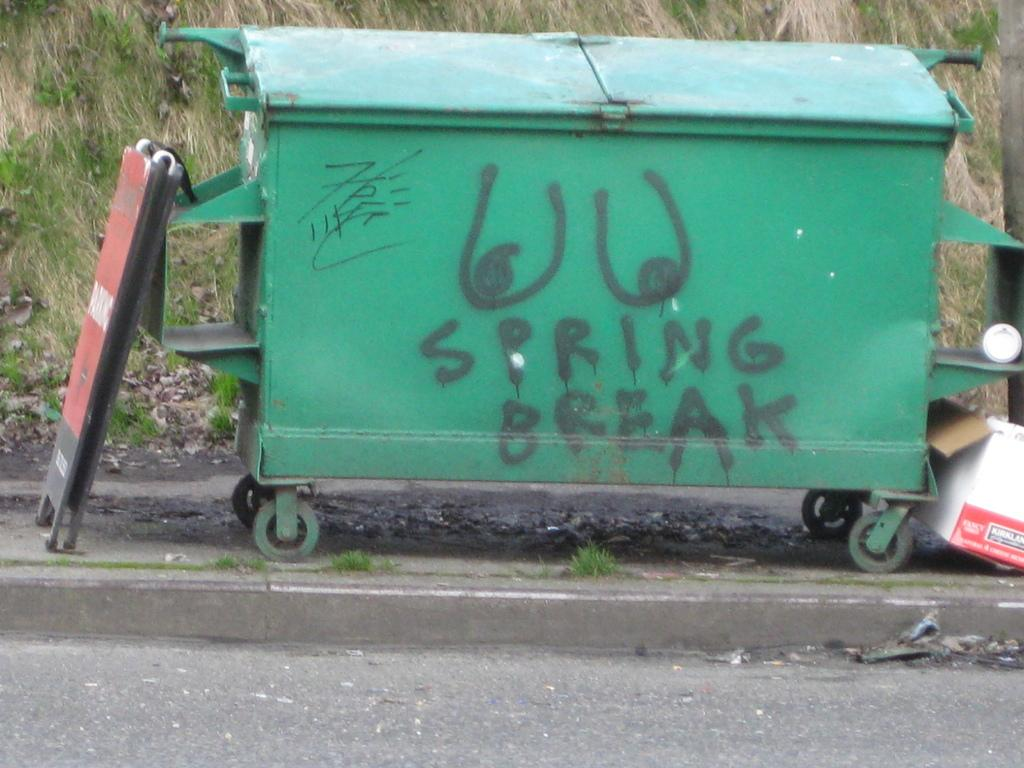<image>
Render a clear and concise summary of the photo. A green trash can on the side of the road has the word spring spray painted on it. 